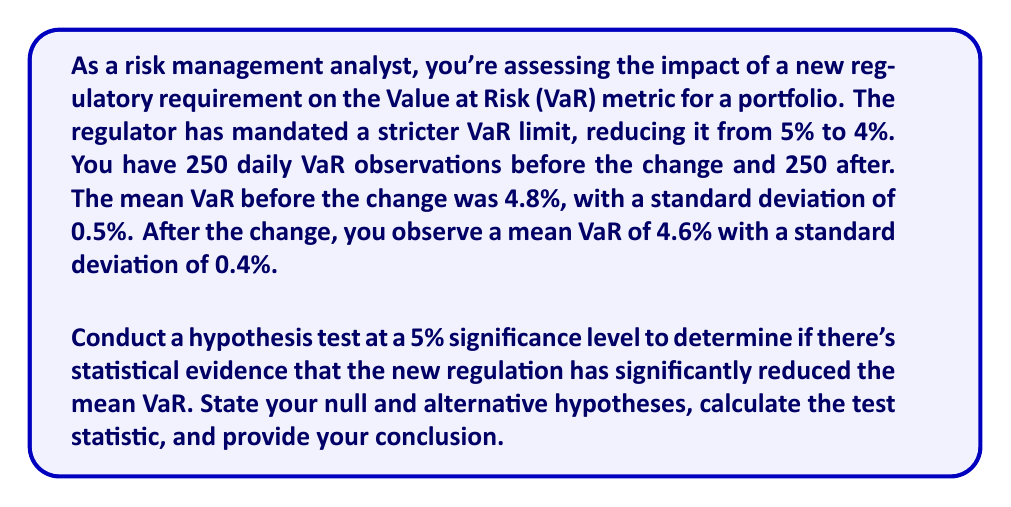Show me your answer to this math problem. To solve this problem, we'll follow these steps:

1) Define the null and alternative hypotheses:
   $H_0: \mu_1 - \mu_2 = 0$ (No difference in means)
   $H_a: \mu_1 - \mu_2 > 0$ (Mean VaR has decreased)

   Where $\mu_1$ is the mean VaR before the change and $\mu_2$ is the mean VaR after the change.

2) Choose the significance level: $\alpha = 0.05$

3) Calculate the test statistic. We'll use a two-sample t-test:

   $t = \frac{\bar{x}_1 - \bar{x}_2}{\sqrt{\frac{s_1^2}{n_1} + \frac{s_2^2}{n_2}}}$

   Where:
   $\bar{x}_1 = 4.8\%$, $s_1 = 0.5\%$, $n_1 = 250$
   $\bar{x}_2 = 4.6\%$, $s_2 = 0.4\%$, $n_2 = 250$

4) Plug in the values:

   $t = \frac{4.8\% - 4.6\%}{\sqrt{\frac{(0.5\%)^2}{250} + \frac{(0.4\%)^2}{250}}}$

   $t = \frac{0.2\%}{\sqrt{\frac{0.0025\%}{250} + \frac{0.0016\%}{250}}}$

   $t = \frac{0.2\%}{\sqrt{0.00001\% + 0.0000064\%}}$

   $t = \frac{0.2\%}{\sqrt{0.0000164\%}}$

   $t = \frac{0.2\%}{0.0405\%} \approx 4.94$

5) Determine the critical value. For a one-tailed test with $\alpha = 0.05$ and df ≈ 498 (conservative estimate), the critical value is approximately 1.65.

6) Compare the test statistic to the critical value:
   4.94 > 1.65, so we reject the null hypothesis.

7) Conclusion: There is statistical evidence at the 5% significance level to conclude that the new regulation has significantly reduced the mean VaR.
Answer: Reject $H_0$; significant evidence of reduced mean VaR (t = 4.94, p < 0.05). 